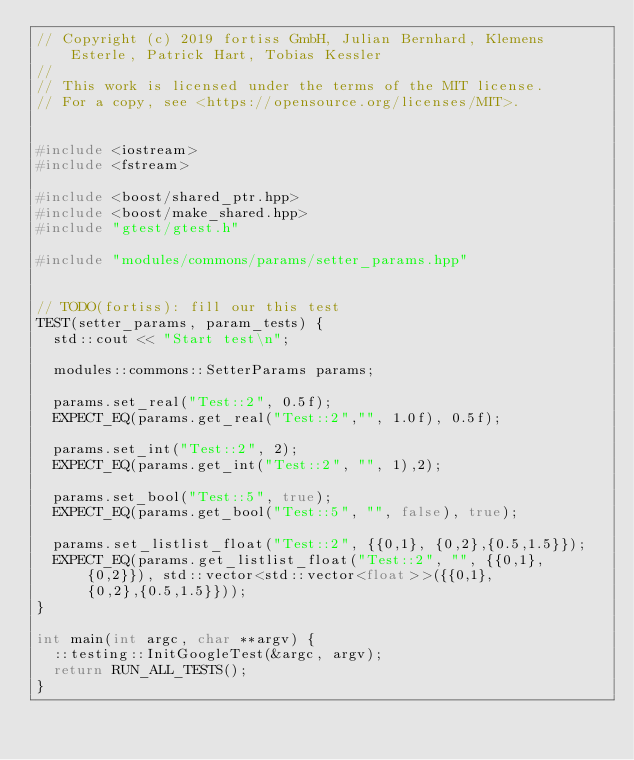<code> <loc_0><loc_0><loc_500><loc_500><_C++_>// Copyright (c) 2019 fortiss GmbH, Julian Bernhard, Klemens Esterle, Patrick Hart, Tobias Kessler
//
// This work is licensed under the terms of the MIT license.
// For a copy, see <https://opensource.org/licenses/MIT>.


#include <iostream>
#include <fstream>

#include <boost/shared_ptr.hpp>
#include <boost/make_shared.hpp>
#include "gtest/gtest.h"

#include "modules/commons/params/setter_params.hpp"


// TODO(fortiss): fill our this test
TEST(setter_params, param_tests) {
  std::cout << "Start test\n";

  modules::commons::SetterParams params;

  params.set_real("Test::2", 0.5f);
  EXPECT_EQ(params.get_real("Test::2","", 1.0f), 0.5f);

  params.set_int("Test::2", 2);
  EXPECT_EQ(params.get_int("Test::2", "", 1),2);

  params.set_bool("Test::5", true);
  EXPECT_EQ(params.get_bool("Test::5", "", false), true);

  params.set_listlist_float("Test::2", {{0,1}, {0,2},{0.5,1.5}});
  EXPECT_EQ(params.get_listlist_float("Test::2", "", {{0,1}, {0,2}}), std::vector<std::vector<float>>({{0,1}, {0,2},{0.5,1.5}}));
}

int main(int argc, char **argv) {
  ::testing::InitGoogleTest(&argc, argv);
  return RUN_ALL_TESTS();
}
</code> 